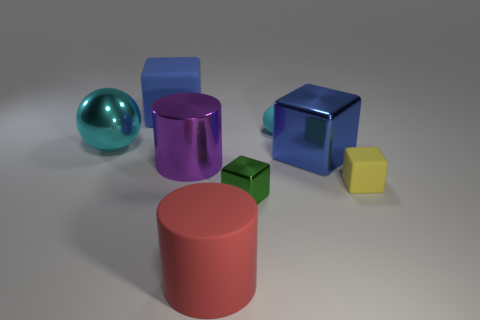There is a metal sphere that is the same color as the small rubber ball; what is its size?
Give a very brief answer. Large. There is a rubber ball that is the same size as the green shiny object; what is its color?
Provide a short and direct response. Cyan. Are the big object that is on the right side of the tiny cyan rubber object and the tiny yellow thing made of the same material?
Offer a very short reply. No. What size is the object that is both on the right side of the purple object and behind the big cyan ball?
Your answer should be compact. Small. There is a matte cube on the right side of the tiny metal block; what is its size?
Give a very brief answer. Small. The object that is the same color as the large metallic cube is what shape?
Provide a succinct answer. Cube. What is the shape of the blue object that is behind the blue object that is in front of the big blue object to the left of the big metallic cylinder?
Provide a short and direct response. Cube. What number of other things are there of the same shape as the large cyan object?
Give a very brief answer. 1. What number of rubber things are big green objects or yellow objects?
Offer a very short reply. 1. There is a large cylinder behind the rubber block in front of the large shiny cube; what is its material?
Offer a terse response. Metal. 